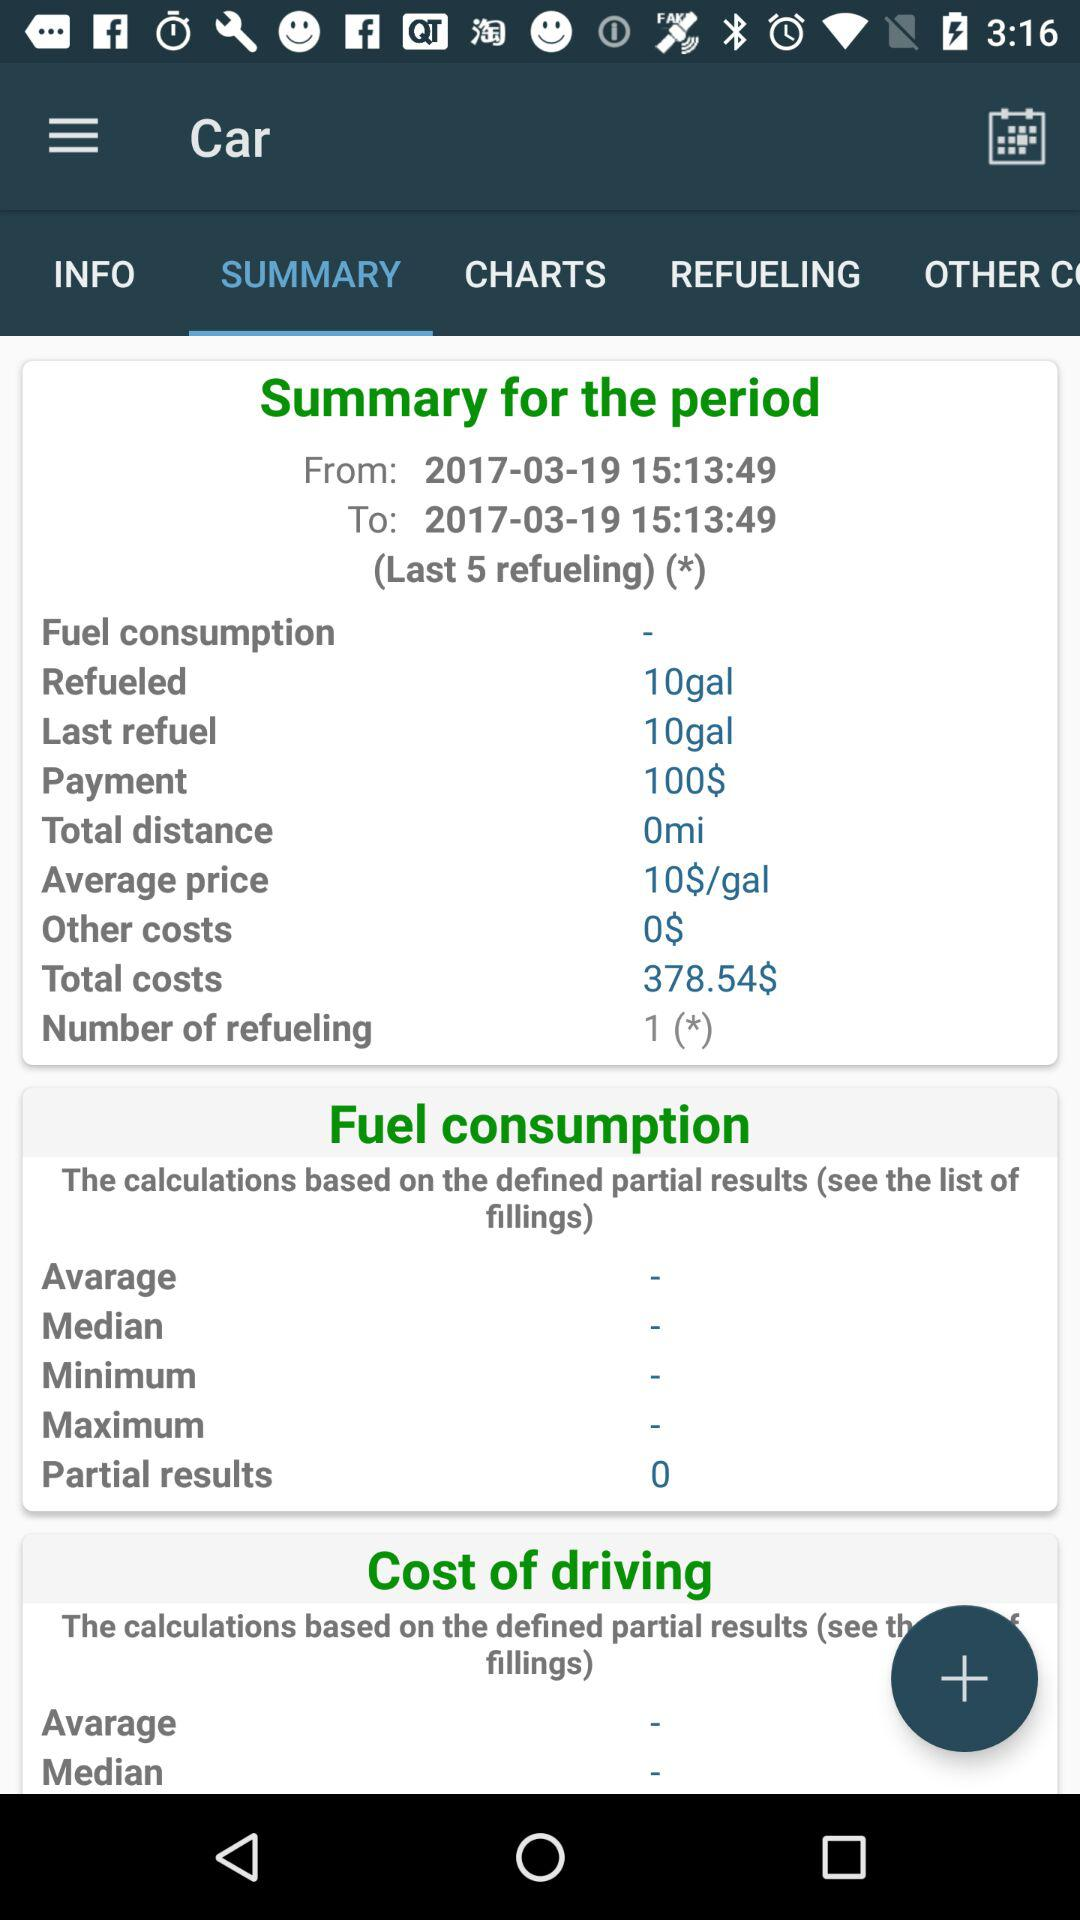How many refuelings were made?
Answer the question using a single word or phrase. 1 